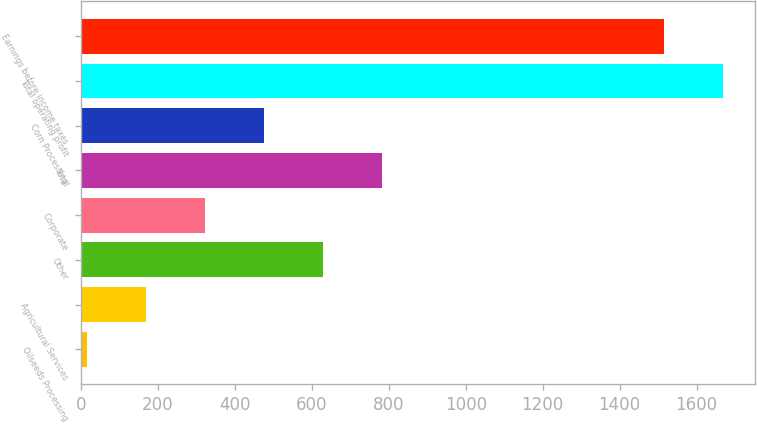<chart> <loc_0><loc_0><loc_500><loc_500><bar_chart><fcel>Oilseeds Processing<fcel>Agricultural Services<fcel>Other<fcel>Corporate<fcel>Total<fcel>Corn Processing<fcel>Total operating profit<fcel>Earnings before income taxes<nl><fcel>15<fcel>168.6<fcel>629.4<fcel>322.2<fcel>783<fcel>475.8<fcel>1669.6<fcel>1516<nl></chart> 